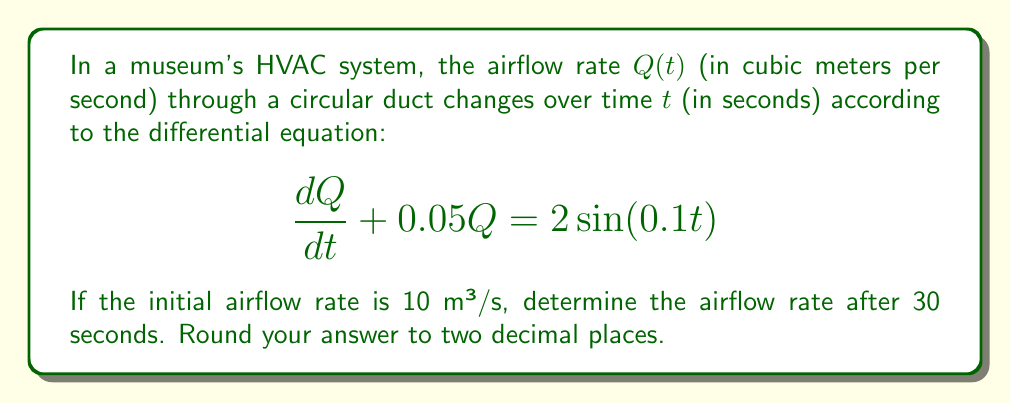Could you help me with this problem? To solve this problem, we need to use the method for solving first-order linear differential equations. The general form of such equations is:

$$\frac{dy}{dx} + P(x)y = Q(x)$$

In our case:
$y = Q$, $x = t$, $P(t) = 0.05$, and $Q(t) = 2\sin(0.1t)$

The solution to this type of equation is given by:

$$y = e^{-\int P(x)dx} \left( \int Q(x)e^{\int P(x)dx}dx + C \right)$$

Step 1: Calculate $\int P(t)dt$
$$\int 0.05 dt = 0.05t$$

Step 2: Find $e^{\int P(t)dt}$
$$e^{\int P(t)dt} = e^{0.05t}$$

Step 3: Calculate $Q(t)e^{\int P(t)dt}$
$$2\sin(0.1t)e^{0.05t}$$

Step 4: Integrate $Q(t)e^{\int P(t)dt}$
$$\int 2\sin(0.1t)e^{0.05t}dt = 2e^{0.05t}\frac{5\sin(0.1t) - 10\cos(0.1t)}{1.25} + C$$

Step 5: Multiply by $e^{-\int P(t)dt}$ to get the general solution
$$Q(t) = \frac{10\sin(0.1t) - 20\cos(0.1t)}{1.25} + Ce^{-0.05t}$$

Step 6: Use the initial condition $Q(0) = 10$ to find $C$
$$10 = \frac{10\sin(0) - 20\cos(0)}{1.25} + C$$
$$C = 26$$

Step 7: Write the particular solution
$$Q(t) = \frac{10\sin(0.1t) - 20\cos(0.1t)}{1.25} + 26e^{-0.05t}$$

Step 8: Calculate $Q(30)$
$$Q(30) = \frac{10\sin(3) - 20\cos(3)}{1.25} + 26e^{-1.5} \approx 11.84$$
Answer: The airflow rate after 30 seconds is approximately 11.84 m³/s. 